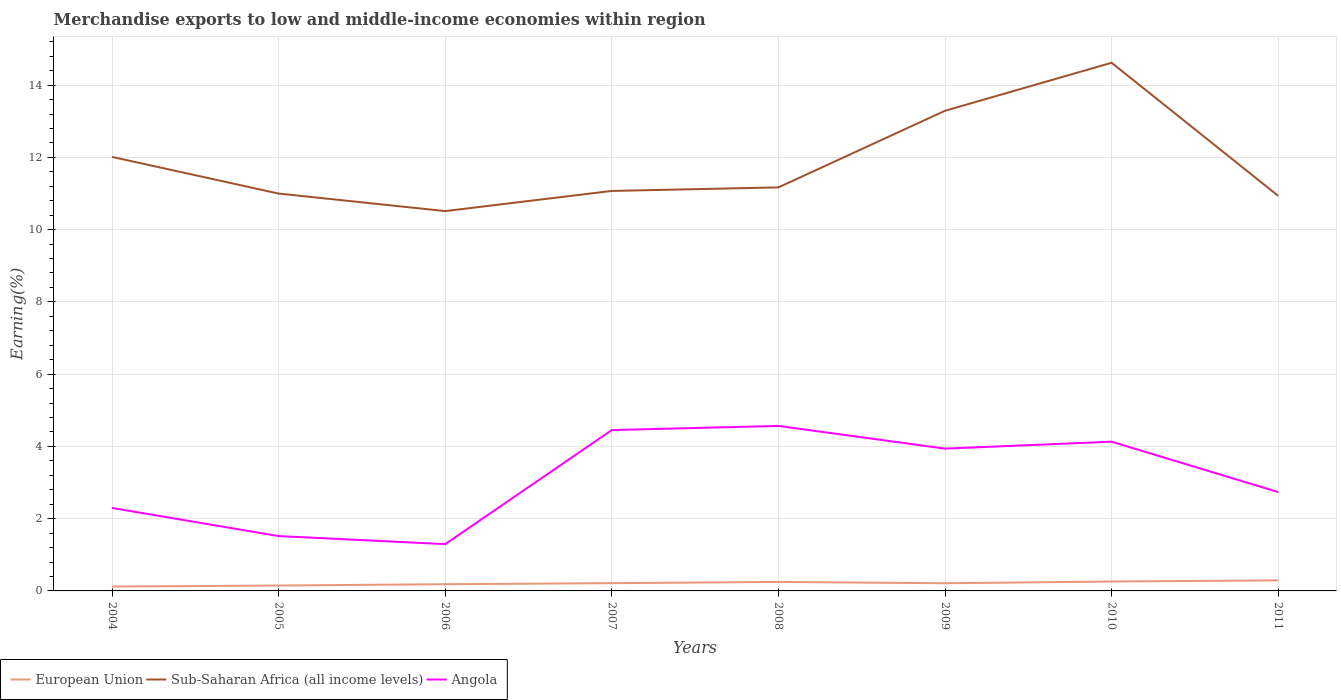Does the line corresponding to Angola intersect with the line corresponding to European Union?
Keep it short and to the point. No. Across all years, what is the maximum percentage of amount earned from merchandise exports in Sub-Saharan Africa (all income levels)?
Your answer should be very brief. 10.51. In which year was the percentage of amount earned from merchandise exports in Angola maximum?
Give a very brief answer. 2006. What is the total percentage of amount earned from merchandise exports in Angola in the graph?
Your answer should be compact. -2.64. What is the difference between the highest and the second highest percentage of amount earned from merchandise exports in Sub-Saharan Africa (all income levels)?
Your answer should be compact. 4.11. How many lines are there?
Your answer should be compact. 3. How many years are there in the graph?
Make the answer very short. 8. Are the values on the major ticks of Y-axis written in scientific E-notation?
Your answer should be compact. No. Does the graph contain any zero values?
Keep it short and to the point. No. Does the graph contain grids?
Your answer should be very brief. Yes. What is the title of the graph?
Offer a terse response. Merchandise exports to low and middle-income economies within region. What is the label or title of the Y-axis?
Offer a very short reply. Earning(%). What is the Earning(%) in European Union in 2004?
Ensure brevity in your answer.  0.12. What is the Earning(%) of Sub-Saharan Africa (all income levels) in 2004?
Your answer should be compact. 12.01. What is the Earning(%) of Angola in 2004?
Your answer should be very brief. 2.3. What is the Earning(%) in European Union in 2005?
Keep it short and to the point. 0.15. What is the Earning(%) of Sub-Saharan Africa (all income levels) in 2005?
Offer a very short reply. 11. What is the Earning(%) in Angola in 2005?
Your answer should be compact. 1.52. What is the Earning(%) of European Union in 2006?
Offer a very short reply. 0.19. What is the Earning(%) of Sub-Saharan Africa (all income levels) in 2006?
Make the answer very short. 10.51. What is the Earning(%) in Angola in 2006?
Provide a succinct answer. 1.3. What is the Earning(%) of European Union in 2007?
Provide a succinct answer. 0.21. What is the Earning(%) in Sub-Saharan Africa (all income levels) in 2007?
Give a very brief answer. 11.07. What is the Earning(%) in Angola in 2007?
Ensure brevity in your answer.  4.45. What is the Earning(%) of European Union in 2008?
Offer a very short reply. 0.25. What is the Earning(%) in Sub-Saharan Africa (all income levels) in 2008?
Your answer should be compact. 11.17. What is the Earning(%) of Angola in 2008?
Give a very brief answer. 4.57. What is the Earning(%) in European Union in 2009?
Offer a terse response. 0.21. What is the Earning(%) of Sub-Saharan Africa (all income levels) in 2009?
Give a very brief answer. 13.29. What is the Earning(%) of Angola in 2009?
Your answer should be very brief. 3.94. What is the Earning(%) in European Union in 2010?
Your answer should be compact. 0.26. What is the Earning(%) of Sub-Saharan Africa (all income levels) in 2010?
Make the answer very short. 14.62. What is the Earning(%) in Angola in 2010?
Provide a short and direct response. 4.13. What is the Earning(%) of European Union in 2011?
Offer a very short reply. 0.29. What is the Earning(%) of Sub-Saharan Africa (all income levels) in 2011?
Your response must be concise. 10.94. What is the Earning(%) in Angola in 2011?
Your response must be concise. 2.74. Across all years, what is the maximum Earning(%) of European Union?
Ensure brevity in your answer.  0.29. Across all years, what is the maximum Earning(%) of Sub-Saharan Africa (all income levels)?
Keep it short and to the point. 14.62. Across all years, what is the maximum Earning(%) in Angola?
Ensure brevity in your answer.  4.57. Across all years, what is the minimum Earning(%) in European Union?
Your answer should be very brief. 0.12. Across all years, what is the minimum Earning(%) of Sub-Saharan Africa (all income levels)?
Give a very brief answer. 10.51. Across all years, what is the minimum Earning(%) in Angola?
Your response must be concise. 1.3. What is the total Earning(%) of European Union in the graph?
Provide a short and direct response. 1.69. What is the total Earning(%) in Sub-Saharan Africa (all income levels) in the graph?
Offer a terse response. 94.61. What is the total Earning(%) of Angola in the graph?
Provide a short and direct response. 24.94. What is the difference between the Earning(%) in European Union in 2004 and that in 2005?
Give a very brief answer. -0.03. What is the difference between the Earning(%) in Angola in 2004 and that in 2005?
Make the answer very short. 0.78. What is the difference between the Earning(%) of European Union in 2004 and that in 2006?
Offer a very short reply. -0.06. What is the difference between the Earning(%) in Sub-Saharan Africa (all income levels) in 2004 and that in 2006?
Give a very brief answer. 1.5. What is the difference between the Earning(%) of Angola in 2004 and that in 2006?
Offer a very short reply. 1. What is the difference between the Earning(%) in European Union in 2004 and that in 2007?
Ensure brevity in your answer.  -0.09. What is the difference between the Earning(%) of Sub-Saharan Africa (all income levels) in 2004 and that in 2007?
Your response must be concise. 0.94. What is the difference between the Earning(%) of Angola in 2004 and that in 2007?
Your answer should be compact. -2.16. What is the difference between the Earning(%) in European Union in 2004 and that in 2008?
Give a very brief answer. -0.13. What is the difference between the Earning(%) in Sub-Saharan Africa (all income levels) in 2004 and that in 2008?
Offer a very short reply. 0.84. What is the difference between the Earning(%) of Angola in 2004 and that in 2008?
Make the answer very short. -2.27. What is the difference between the Earning(%) in European Union in 2004 and that in 2009?
Your response must be concise. -0.09. What is the difference between the Earning(%) in Sub-Saharan Africa (all income levels) in 2004 and that in 2009?
Your answer should be very brief. -1.28. What is the difference between the Earning(%) in Angola in 2004 and that in 2009?
Your response must be concise. -1.64. What is the difference between the Earning(%) in European Union in 2004 and that in 2010?
Your response must be concise. -0.14. What is the difference between the Earning(%) in Sub-Saharan Africa (all income levels) in 2004 and that in 2010?
Provide a short and direct response. -2.61. What is the difference between the Earning(%) in Angola in 2004 and that in 2010?
Give a very brief answer. -1.83. What is the difference between the Earning(%) in European Union in 2004 and that in 2011?
Offer a very short reply. -0.17. What is the difference between the Earning(%) of Sub-Saharan Africa (all income levels) in 2004 and that in 2011?
Keep it short and to the point. 1.08. What is the difference between the Earning(%) of Angola in 2004 and that in 2011?
Provide a succinct answer. -0.44. What is the difference between the Earning(%) in European Union in 2005 and that in 2006?
Your answer should be very brief. -0.04. What is the difference between the Earning(%) in Sub-Saharan Africa (all income levels) in 2005 and that in 2006?
Ensure brevity in your answer.  0.48. What is the difference between the Earning(%) of Angola in 2005 and that in 2006?
Provide a succinct answer. 0.22. What is the difference between the Earning(%) of European Union in 2005 and that in 2007?
Provide a succinct answer. -0.07. What is the difference between the Earning(%) in Sub-Saharan Africa (all income levels) in 2005 and that in 2007?
Ensure brevity in your answer.  -0.07. What is the difference between the Earning(%) in Angola in 2005 and that in 2007?
Make the answer very short. -2.93. What is the difference between the Earning(%) in European Union in 2005 and that in 2008?
Your answer should be compact. -0.1. What is the difference between the Earning(%) in Sub-Saharan Africa (all income levels) in 2005 and that in 2008?
Your answer should be compact. -0.17. What is the difference between the Earning(%) in Angola in 2005 and that in 2008?
Your answer should be compact. -3.05. What is the difference between the Earning(%) of European Union in 2005 and that in 2009?
Offer a terse response. -0.06. What is the difference between the Earning(%) of Sub-Saharan Africa (all income levels) in 2005 and that in 2009?
Your answer should be compact. -2.29. What is the difference between the Earning(%) in Angola in 2005 and that in 2009?
Offer a terse response. -2.42. What is the difference between the Earning(%) of European Union in 2005 and that in 2010?
Keep it short and to the point. -0.11. What is the difference between the Earning(%) of Sub-Saharan Africa (all income levels) in 2005 and that in 2010?
Provide a succinct answer. -3.62. What is the difference between the Earning(%) of Angola in 2005 and that in 2010?
Provide a succinct answer. -2.61. What is the difference between the Earning(%) in European Union in 2005 and that in 2011?
Provide a succinct answer. -0.14. What is the difference between the Earning(%) of Sub-Saharan Africa (all income levels) in 2005 and that in 2011?
Ensure brevity in your answer.  0.06. What is the difference between the Earning(%) of Angola in 2005 and that in 2011?
Offer a very short reply. -1.22. What is the difference between the Earning(%) in European Union in 2006 and that in 2007?
Offer a terse response. -0.03. What is the difference between the Earning(%) in Sub-Saharan Africa (all income levels) in 2006 and that in 2007?
Ensure brevity in your answer.  -0.56. What is the difference between the Earning(%) of Angola in 2006 and that in 2007?
Provide a short and direct response. -3.16. What is the difference between the Earning(%) of European Union in 2006 and that in 2008?
Provide a succinct answer. -0.06. What is the difference between the Earning(%) of Sub-Saharan Africa (all income levels) in 2006 and that in 2008?
Your answer should be compact. -0.66. What is the difference between the Earning(%) of Angola in 2006 and that in 2008?
Keep it short and to the point. -3.27. What is the difference between the Earning(%) in European Union in 2006 and that in 2009?
Offer a terse response. -0.03. What is the difference between the Earning(%) in Sub-Saharan Africa (all income levels) in 2006 and that in 2009?
Your answer should be very brief. -2.78. What is the difference between the Earning(%) of Angola in 2006 and that in 2009?
Your answer should be compact. -2.64. What is the difference between the Earning(%) in European Union in 2006 and that in 2010?
Give a very brief answer. -0.07. What is the difference between the Earning(%) in Sub-Saharan Africa (all income levels) in 2006 and that in 2010?
Provide a short and direct response. -4.11. What is the difference between the Earning(%) in Angola in 2006 and that in 2010?
Your answer should be compact. -2.84. What is the difference between the Earning(%) in European Union in 2006 and that in 2011?
Provide a succinct answer. -0.11. What is the difference between the Earning(%) of Sub-Saharan Africa (all income levels) in 2006 and that in 2011?
Ensure brevity in your answer.  -0.42. What is the difference between the Earning(%) of Angola in 2006 and that in 2011?
Ensure brevity in your answer.  -1.44. What is the difference between the Earning(%) in European Union in 2007 and that in 2008?
Ensure brevity in your answer.  -0.03. What is the difference between the Earning(%) of Sub-Saharan Africa (all income levels) in 2007 and that in 2008?
Keep it short and to the point. -0.1. What is the difference between the Earning(%) in Angola in 2007 and that in 2008?
Keep it short and to the point. -0.11. What is the difference between the Earning(%) in European Union in 2007 and that in 2009?
Keep it short and to the point. 0. What is the difference between the Earning(%) in Sub-Saharan Africa (all income levels) in 2007 and that in 2009?
Keep it short and to the point. -2.22. What is the difference between the Earning(%) in Angola in 2007 and that in 2009?
Offer a terse response. 0.51. What is the difference between the Earning(%) in European Union in 2007 and that in 2010?
Keep it short and to the point. -0.05. What is the difference between the Earning(%) in Sub-Saharan Africa (all income levels) in 2007 and that in 2010?
Offer a very short reply. -3.55. What is the difference between the Earning(%) in Angola in 2007 and that in 2010?
Offer a very short reply. 0.32. What is the difference between the Earning(%) of European Union in 2007 and that in 2011?
Offer a terse response. -0.08. What is the difference between the Earning(%) of Sub-Saharan Africa (all income levels) in 2007 and that in 2011?
Provide a succinct answer. 0.14. What is the difference between the Earning(%) in Angola in 2007 and that in 2011?
Your response must be concise. 1.72. What is the difference between the Earning(%) in European Union in 2008 and that in 2009?
Offer a terse response. 0.04. What is the difference between the Earning(%) in Sub-Saharan Africa (all income levels) in 2008 and that in 2009?
Your answer should be compact. -2.12. What is the difference between the Earning(%) in Angola in 2008 and that in 2009?
Provide a short and direct response. 0.63. What is the difference between the Earning(%) of European Union in 2008 and that in 2010?
Offer a very short reply. -0.01. What is the difference between the Earning(%) in Sub-Saharan Africa (all income levels) in 2008 and that in 2010?
Ensure brevity in your answer.  -3.45. What is the difference between the Earning(%) of Angola in 2008 and that in 2010?
Your answer should be very brief. 0.44. What is the difference between the Earning(%) in European Union in 2008 and that in 2011?
Provide a short and direct response. -0.04. What is the difference between the Earning(%) of Sub-Saharan Africa (all income levels) in 2008 and that in 2011?
Ensure brevity in your answer.  0.23. What is the difference between the Earning(%) of Angola in 2008 and that in 2011?
Your answer should be compact. 1.83. What is the difference between the Earning(%) in European Union in 2009 and that in 2010?
Provide a short and direct response. -0.05. What is the difference between the Earning(%) in Sub-Saharan Africa (all income levels) in 2009 and that in 2010?
Your response must be concise. -1.33. What is the difference between the Earning(%) of Angola in 2009 and that in 2010?
Give a very brief answer. -0.19. What is the difference between the Earning(%) of European Union in 2009 and that in 2011?
Offer a terse response. -0.08. What is the difference between the Earning(%) of Sub-Saharan Africa (all income levels) in 2009 and that in 2011?
Your answer should be very brief. 2.35. What is the difference between the Earning(%) of Angola in 2009 and that in 2011?
Your answer should be compact. 1.2. What is the difference between the Earning(%) of European Union in 2010 and that in 2011?
Offer a terse response. -0.03. What is the difference between the Earning(%) in Sub-Saharan Africa (all income levels) in 2010 and that in 2011?
Your response must be concise. 3.68. What is the difference between the Earning(%) in Angola in 2010 and that in 2011?
Provide a succinct answer. 1.39. What is the difference between the Earning(%) of European Union in 2004 and the Earning(%) of Sub-Saharan Africa (all income levels) in 2005?
Your answer should be very brief. -10.88. What is the difference between the Earning(%) of European Union in 2004 and the Earning(%) of Angola in 2005?
Your response must be concise. -1.4. What is the difference between the Earning(%) of Sub-Saharan Africa (all income levels) in 2004 and the Earning(%) of Angola in 2005?
Provide a succinct answer. 10.5. What is the difference between the Earning(%) of European Union in 2004 and the Earning(%) of Sub-Saharan Africa (all income levels) in 2006?
Your answer should be compact. -10.39. What is the difference between the Earning(%) in European Union in 2004 and the Earning(%) in Angola in 2006?
Offer a very short reply. -1.17. What is the difference between the Earning(%) in Sub-Saharan Africa (all income levels) in 2004 and the Earning(%) in Angola in 2006?
Your answer should be compact. 10.72. What is the difference between the Earning(%) in European Union in 2004 and the Earning(%) in Sub-Saharan Africa (all income levels) in 2007?
Your answer should be very brief. -10.95. What is the difference between the Earning(%) of European Union in 2004 and the Earning(%) of Angola in 2007?
Offer a very short reply. -4.33. What is the difference between the Earning(%) in Sub-Saharan Africa (all income levels) in 2004 and the Earning(%) in Angola in 2007?
Keep it short and to the point. 7.56. What is the difference between the Earning(%) in European Union in 2004 and the Earning(%) in Sub-Saharan Africa (all income levels) in 2008?
Keep it short and to the point. -11.05. What is the difference between the Earning(%) of European Union in 2004 and the Earning(%) of Angola in 2008?
Offer a terse response. -4.45. What is the difference between the Earning(%) in Sub-Saharan Africa (all income levels) in 2004 and the Earning(%) in Angola in 2008?
Give a very brief answer. 7.45. What is the difference between the Earning(%) in European Union in 2004 and the Earning(%) in Sub-Saharan Africa (all income levels) in 2009?
Ensure brevity in your answer.  -13.17. What is the difference between the Earning(%) of European Union in 2004 and the Earning(%) of Angola in 2009?
Provide a succinct answer. -3.82. What is the difference between the Earning(%) in Sub-Saharan Africa (all income levels) in 2004 and the Earning(%) in Angola in 2009?
Provide a short and direct response. 8.07. What is the difference between the Earning(%) of European Union in 2004 and the Earning(%) of Sub-Saharan Africa (all income levels) in 2010?
Provide a succinct answer. -14.5. What is the difference between the Earning(%) of European Union in 2004 and the Earning(%) of Angola in 2010?
Your answer should be very brief. -4.01. What is the difference between the Earning(%) in Sub-Saharan Africa (all income levels) in 2004 and the Earning(%) in Angola in 2010?
Your response must be concise. 7.88. What is the difference between the Earning(%) of European Union in 2004 and the Earning(%) of Sub-Saharan Africa (all income levels) in 2011?
Offer a very short reply. -10.81. What is the difference between the Earning(%) of European Union in 2004 and the Earning(%) of Angola in 2011?
Offer a terse response. -2.62. What is the difference between the Earning(%) in Sub-Saharan Africa (all income levels) in 2004 and the Earning(%) in Angola in 2011?
Offer a terse response. 9.28. What is the difference between the Earning(%) in European Union in 2005 and the Earning(%) in Sub-Saharan Africa (all income levels) in 2006?
Keep it short and to the point. -10.36. What is the difference between the Earning(%) of European Union in 2005 and the Earning(%) of Angola in 2006?
Your answer should be very brief. -1.15. What is the difference between the Earning(%) in Sub-Saharan Africa (all income levels) in 2005 and the Earning(%) in Angola in 2006?
Your answer should be very brief. 9.7. What is the difference between the Earning(%) in European Union in 2005 and the Earning(%) in Sub-Saharan Africa (all income levels) in 2007?
Offer a very short reply. -10.92. What is the difference between the Earning(%) of European Union in 2005 and the Earning(%) of Angola in 2007?
Your answer should be compact. -4.3. What is the difference between the Earning(%) in Sub-Saharan Africa (all income levels) in 2005 and the Earning(%) in Angola in 2007?
Your response must be concise. 6.55. What is the difference between the Earning(%) of European Union in 2005 and the Earning(%) of Sub-Saharan Africa (all income levels) in 2008?
Make the answer very short. -11.02. What is the difference between the Earning(%) of European Union in 2005 and the Earning(%) of Angola in 2008?
Make the answer very short. -4.42. What is the difference between the Earning(%) in Sub-Saharan Africa (all income levels) in 2005 and the Earning(%) in Angola in 2008?
Offer a very short reply. 6.43. What is the difference between the Earning(%) in European Union in 2005 and the Earning(%) in Sub-Saharan Africa (all income levels) in 2009?
Keep it short and to the point. -13.14. What is the difference between the Earning(%) in European Union in 2005 and the Earning(%) in Angola in 2009?
Keep it short and to the point. -3.79. What is the difference between the Earning(%) of Sub-Saharan Africa (all income levels) in 2005 and the Earning(%) of Angola in 2009?
Give a very brief answer. 7.06. What is the difference between the Earning(%) of European Union in 2005 and the Earning(%) of Sub-Saharan Africa (all income levels) in 2010?
Make the answer very short. -14.47. What is the difference between the Earning(%) in European Union in 2005 and the Earning(%) in Angola in 2010?
Your answer should be compact. -3.98. What is the difference between the Earning(%) of Sub-Saharan Africa (all income levels) in 2005 and the Earning(%) of Angola in 2010?
Offer a terse response. 6.87. What is the difference between the Earning(%) of European Union in 2005 and the Earning(%) of Sub-Saharan Africa (all income levels) in 2011?
Your answer should be compact. -10.79. What is the difference between the Earning(%) in European Union in 2005 and the Earning(%) in Angola in 2011?
Give a very brief answer. -2.59. What is the difference between the Earning(%) of Sub-Saharan Africa (all income levels) in 2005 and the Earning(%) of Angola in 2011?
Your answer should be compact. 8.26. What is the difference between the Earning(%) in European Union in 2006 and the Earning(%) in Sub-Saharan Africa (all income levels) in 2007?
Offer a terse response. -10.89. What is the difference between the Earning(%) in European Union in 2006 and the Earning(%) in Angola in 2007?
Your answer should be compact. -4.27. What is the difference between the Earning(%) of Sub-Saharan Africa (all income levels) in 2006 and the Earning(%) of Angola in 2007?
Offer a very short reply. 6.06. What is the difference between the Earning(%) of European Union in 2006 and the Earning(%) of Sub-Saharan Africa (all income levels) in 2008?
Your answer should be very brief. -10.98. What is the difference between the Earning(%) of European Union in 2006 and the Earning(%) of Angola in 2008?
Keep it short and to the point. -4.38. What is the difference between the Earning(%) of Sub-Saharan Africa (all income levels) in 2006 and the Earning(%) of Angola in 2008?
Provide a succinct answer. 5.95. What is the difference between the Earning(%) of European Union in 2006 and the Earning(%) of Sub-Saharan Africa (all income levels) in 2009?
Make the answer very short. -13.1. What is the difference between the Earning(%) of European Union in 2006 and the Earning(%) of Angola in 2009?
Make the answer very short. -3.75. What is the difference between the Earning(%) in Sub-Saharan Africa (all income levels) in 2006 and the Earning(%) in Angola in 2009?
Offer a terse response. 6.58. What is the difference between the Earning(%) in European Union in 2006 and the Earning(%) in Sub-Saharan Africa (all income levels) in 2010?
Offer a very short reply. -14.43. What is the difference between the Earning(%) in European Union in 2006 and the Earning(%) in Angola in 2010?
Your answer should be compact. -3.94. What is the difference between the Earning(%) in Sub-Saharan Africa (all income levels) in 2006 and the Earning(%) in Angola in 2010?
Provide a short and direct response. 6.38. What is the difference between the Earning(%) of European Union in 2006 and the Earning(%) of Sub-Saharan Africa (all income levels) in 2011?
Keep it short and to the point. -10.75. What is the difference between the Earning(%) of European Union in 2006 and the Earning(%) of Angola in 2011?
Make the answer very short. -2.55. What is the difference between the Earning(%) in Sub-Saharan Africa (all income levels) in 2006 and the Earning(%) in Angola in 2011?
Make the answer very short. 7.78. What is the difference between the Earning(%) in European Union in 2007 and the Earning(%) in Sub-Saharan Africa (all income levels) in 2008?
Your response must be concise. -10.95. What is the difference between the Earning(%) of European Union in 2007 and the Earning(%) of Angola in 2008?
Your response must be concise. -4.35. What is the difference between the Earning(%) of Sub-Saharan Africa (all income levels) in 2007 and the Earning(%) of Angola in 2008?
Keep it short and to the point. 6.5. What is the difference between the Earning(%) of European Union in 2007 and the Earning(%) of Sub-Saharan Africa (all income levels) in 2009?
Make the answer very short. -13.07. What is the difference between the Earning(%) in European Union in 2007 and the Earning(%) in Angola in 2009?
Keep it short and to the point. -3.72. What is the difference between the Earning(%) in Sub-Saharan Africa (all income levels) in 2007 and the Earning(%) in Angola in 2009?
Offer a terse response. 7.13. What is the difference between the Earning(%) in European Union in 2007 and the Earning(%) in Sub-Saharan Africa (all income levels) in 2010?
Your answer should be compact. -14.4. What is the difference between the Earning(%) of European Union in 2007 and the Earning(%) of Angola in 2010?
Give a very brief answer. -3.92. What is the difference between the Earning(%) of Sub-Saharan Africa (all income levels) in 2007 and the Earning(%) of Angola in 2010?
Offer a terse response. 6.94. What is the difference between the Earning(%) of European Union in 2007 and the Earning(%) of Sub-Saharan Africa (all income levels) in 2011?
Your answer should be very brief. -10.72. What is the difference between the Earning(%) in European Union in 2007 and the Earning(%) in Angola in 2011?
Offer a terse response. -2.52. What is the difference between the Earning(%) in Sub-Saharan Africa (all income levels) in 2007 and the Earning(%) in Angola in 2011?
Your response must be concise. 8.34. What is the difference between the Earning(%) of European Union in 2008 and the Earning(%) of Sub-Saharan Africa (all income levels) in 2009?
Your response must be concise. -13.04. What is the difference between the Earning(%) of European Union in 2008 and the Earning(%) of Angola in 2009?
Give a very brief answer. -3.69. What is the difference between the Earning(%) of Sub-Saharan Africa (all income levels) in 2008 and the Earning(%) of Angola in 2009?
Offer a terse response. 7.23. What is the difference between the Earning(%) in European Union in 2008 and the Earning(%) in Sub-Saharan Africa (all income levels) in 2010?
Provide a short and direct response. -14.37. What is the difference between the Earning(%) of European Union in 2008 and the Earning(%) of Angola in 2010?
Provide a succinct answer. -3.88. What is the difference between the Earning(%) in Sub-Saharan Africa (all income levels) in 2008 and the Earning(%) in Angola in 2010?
Offer a very short reply. 7.04. What is the difference between the Earning(%) of European Union in 2008 and the Earning(%) of Sub-Saharan Africa (all income levels) in 2011?
Your answer should be compact. -10.69. What is the difference between the Earning(%) of European Union in 2008 and the Earning(%) of Angola in 2011?
Keep it short and to the point. -2.49. What is the difference between the Earning(%) in Sub-Saharan Africa (all income levels) in 2008 and the Earning(%) in Angola in 2011?
Make the answer very short. 8.43. What is the difference between the Earning(%) in European Union in 2009 and the Earning(%) in Sub-Saharan Africa (all income levels) in 2010?
Keep it short and to the point. -14.41. What is the difference between the Earning(%) of European Union in 2009 and the Earning(%) of Angola in 2010?
Offer a very short reply. -3.92. What is the difference between the Earning(%) in Sub-Saharan Africa (all income levels) in 2009 and the Earning(%) in Angola in 2010?
Your answer should be compact. 9.16. What is the difference between the Earning(%) in European Union in 2009 and the Earning(%) in Sub-Saharan Africa (all income levels) in 2011?
Provide a short and direct response. -10.72. What is the difference between the Earning(%) of European Union in 2009 and the Earning(%) of Angola in 2011?
Your answer should be very brief. -2.52. What is the difference between the Earning(%) in Sub-Saharan Africa (all income levels) in 2009 and the Earning(%) in Angola in 2011?
Provide a short and direct response. 10.55. What is the difference between the Earning(%) of European Union in 2010 and the Earning(%) of Sub-Saharan Africa (all income levels) in 2011?
Offer a very short reply. -10.68. What is the difference between the Earning(%) in European Union in 2010 and the Earning(%) in Angola in 2011?
Offer a terse response. -2.48. What is the difference between the Earning(%) in Sub-Saharan Africa (all income levels) in 2010 and the Earning(%) in Angola in 2011?
Provide a succinct answer. 11.88. What is the average Earning(%) in European Union per year?
Offer a terse response. 0.21. What is the average Earning(%) of Sub-Saharan Africa (all income levels) per year?
Make the answer very short. 11.83. What is the average Earning(%) in Angola per year?
Provide a succinct answer. 3.12. In the year 2004, what is the difference between the Earning(%) of European Union and Earning(%) of Sub-Saharan Africa (all income levels)?
Give a very brief answer. -11.89. In the year 2004, what is the difference between the Earning(%) in European Union and Earning(%) in Angola?
Give a very brief answer. -2.18. In the year 2004, what is the difference between the Earning(%) in Sub-Saharan Africa (all income levels) and Earning(%) in Angola?
Provide a short and direct response. 9.72. In the year 2005, what is the difference between the Earning(%) of European Union and Earning(%) of Sub-Saharan Africa (all income levels)?
Ensure brevity in your answer.  -10.85. In the year 2005, what is the difference between the Earning(%) in European Union and Earning(%) in Angola?
Keep it short and to the point. -1.37. In the year 2005, what is the difference between the Earning(%) of Sub-Saharan Africa (all income levels) and Earning(%) of Angola?
Give a very brief answer. 9.48. In the year 2006, what is the difference between the Earning(%) of European Union and Earning(%) of Sub-Saharan Africa (all income levels)?
Provide a short and direct response. -10.33. In the year 2006, what is the difference between the Earning(%) of European Union and Earning(%) of Angola?
Provide a short and direct response. -1.11. In the year 2006, what is the difference between the Earning(%) of Sub-Saharan Africa (all income levels) and Earning(%) of Angola?
Your response must be concise. 9.22. In the year 2007, what is the difference between the Earning(%) in European Union and Earning(%) in Sub-Saharan Africa (all income levels)?
Give a very brief answer. -10.86. In the year 2007, what is the difference between the Earning(%) in European Union and Earning(%) in Angola?
Your answer should be very brief. -4.24. In the year 2007, what is the difference between the Earning(%) in Sub-Saharan Africa (all income levels) and Earning(%) in Angola?
Make the answer very short. 6.62. In the year 2008, what is the difference between the Earning(%) in European Union and Earning(%) in Sub-Saharan Africa (all income levels)?
Ensure brevity in your answer.  -10.92. In the year 2008, what is the difference between the Earning(%) in European Union and Earning(%) in Angola?
Provide a short and direct response. -4.32. In the year 2008, what is the difference between the Earning(%) in Sub-Saharan Africa (all income levels) and Earning(%) in Angola?
Keep it short and to the point. 6.6. In the year 2009, what is the difference between the Earning(%) of European Union and Earning(%) of Sub-Saharan Africa (all income levels)?
Ensure brevity in your answer.  -13.08. In the year 2009, what is the difference between the Earning(%) in European Union and Earning(%) in Angola?
Your answer should be very brief. -3.73. In the year 2009, what is the difference between the Earning(%) in Sub-Saharan Africa (all income levels) and Earning(%) in Angola?
Keep it short and to the point. 9.35. In the year 2010, what is the difference between the Earning(%) of European Union and Earning(%) of Sub-Saharan Africa (all income levels)?
Offer a terse response. -14.36. In the year 2010, what is the difference between the Earning(%) in European Union and Earning(%) in Angola?
Your response must be concise. -3.87. In the year 2010, what is the difference between the Earning(%) in Sub-Saharan Africa (all income levels) and Earning(%) in Angola?
Provide a short and direct response. 10.49. In the year 2011, what is the difference between the Earning(%) in European Union and Earning(%) in Sub-Saharan Africa (all income levels)?
Provide a short and direct response. -10.64. In the year 2011, what is the difference between the Earning(%) in European Union and Earning(%) in Angola?
Your response must be concise. -2.44. In the year 2011, what is the difference between the Earning(%) of Sub-Saharan Africa (all income levels) and Earning(%) of Angola?
Offer a terse response. 8.2. What is the ratio of the Earning(%) in European Union in 2004 to that in 2005?
Give a very brief answer. 0.81. What is the ratio of the Earning(%) of Sub-Saharan Africa (all income levels) in 2004 to that in 2005?
Your answer should be compact. 1.09. What is the ratio of the Earning(%) of Angola in 2004 to that in 2005?
Your answer should be compact. 1.51. What is the ratio of the Earning(%) in European Union in 2004 to that in 2006?
Your answer should be compact. 0.65. What is the ratio of the Earning(%) of Sub-Saharan Africa (all income levels) in 2004 to that in 2006?
Offer a very short reply. 1.14. What is the ratio of the Earning(%) of Angola in 2004 to that in 2006?
Make the answer very short. 1.77. What is the ratio of the Earning(%) in European Union in 2004 to that in 2007?
Ensure brevity in your answer.  0.56. What is the ratio of the Earning(%) in Sub-Saharan Africa (all income levels) in 2004 to that in 2007?
Your response must be concise. 1.09. What is the ratio of the Earning(%) in Angola in 2004 to that in 2007?
Your answer should be compact. 0.52. What is the ratio of the Earning(%) of European Union in 2004 to that in 2008?
Offer a terse response. 0.49. What is the ratio of the Earning(%) of Sub-Saharan Africa (all income levels) in 2004 to that in 2008?
Your response must be concise. 1.08. What is the ratio of the Earning(%) of Angola in 2004 to that in 2008?
Provide a short and direct response. 0.5. What is the ratio of the Earning(%) in European Union in 2004 to that in 2009?
Offer a very short reply. 0.57. What is the ratio of the Earning(%) in Sub-Saharan Africa (all income levels) in 2004 to that in 2009?
Your answer should be compact. 0.9. What is the ratio of the Earning(%) of Angola in 2004 to that in 2009?
Give a very brief answer. 0.58. What is the ratio of the Earning(%) of European Union in 2004 to that in 2010?
Your answer should be compact. 0.46. What is the ratio of the Earning(%) of Sub-Saharan Africa (all income levels) in 2004 to that in 2010?
Provide a short and direct response. 0.82. What is the ratio of the Earning(%) of Angola in 2004 to that in 2010?
Offer a terse response. 0.56. What is the ratio of the Earning(%) of European Union in 2004 to that in 2011?
Provide a short and direct response. 0.41. What is the ratio of the Earning(%) in Sub-Saharan Africa (all income levels) in 2004 to that in 2011?
Ensure brevity in your answer.  1.1. What is the ratio of the Earning(%) in Angola in 2004 to that in 2011?
Give a very brief answer. 0.84. What is the ratio of the Earning(%) of European Union in 2005 to that in 2006?
Provide a succinct answer. 0.8. What is the ratio of the Earning(%) of Sub-Saharan Africa (all income levels) in 2005 to that in 2006?
Provide a short and direct response. 1.05. What is the ratio of the Earning(%) in Angola in 2005 to that in 2006?
Provide a short and direct response. 1.17. What is the ratio of the Earning(%) in European Union in 2005 to that in 2007?
Offer a very short reply. 0.69. What is the ratio of the Earning(%) of Angola in 2005 to that in 2007?
Your response must be concise. 0.34. What is the ratio of the Earning(%) in European Union in 2005 to that in 2008?
Ensure brevity in your answer.  0.6. What is the ratio of the Earning(%) in Sub-Saharan Africa (all income levels) in 2005 to that in 2008?
Your answer should be compact. 0.98. What is the ratio of the Earning(%) in Angola in 2005 to that in 2008?
Offer a terse response. 0.33. What is the ratio of the Earning(%) of European Union in 2005 to that in 2009?
Your answer should be very brief. 0.7. What is the ratio of the Earning(%) of Sub-Saharan Africa (all income levels) in 2005 to that in 2009?
Offer a very short reply. 0.83. What is the ratio of the Earning(%) of Angola in 2005 to that in 2009?
Provide a short and direct response. 0.39. What is the ratio of the Earning(%) in European Union in 2005 to that in 2010?
Provide a short and direct response. 0.57. What is the ratio of the Earning(%) in Sub-Saharan Africa (all income levels) in 2005 to that in 2010?
Offer a terse response. 0.75. What is the ratio of the Earning(%) in Angola in 2005 to that in 2010?
Provide a succinct answer. 0.37. What is the ratio of the Earning(%) in European Union in 2005 to that in 2011?
Your response must be concise. 0.51. What is the ratio of the Earning(%) in Angola in 2005 to that in 2011?
Offer a very short reply. 0.55. What is the ratio of the Earning(%) of European Union in 2006 to that in 2007?
Offer a terse response. 0.86. What is the ratio of the Earning(%) of Sub-Saharan Africa (all income levels) in 2006 to that in 2007?
Provide a short and direct response. 0.95. What is the ratio of the Earning(%) of Angola in 2006 to that in 2007?
Your answer should be very brief. 0.29. What is the ratio of the Earning(%) in European Union in 2006 to that in 2008?
Offer a very short reply. 0.75. What is the ratio of the Earning(%) of Sub-Saharan Africa (all income levels) in 2006 to that in 2008?
Provide a succinct answer. 0.94. What is the ratio of the Earning(%) of Angola in 2006 to that in 2008?
Provide a succinct answer. 0.28. What is the ratio of the Earning(%) of European Union in 2006 to that in 2009?
Your answer should be very brief. 0.87. What is the ratio of the Earning(%) in Sub-Saharan Africa (all income levels) in 2006 to that in 2009?
Your answer should be very brief. 0.79. What is the ratio of the Earning(%) in Angola in 2006 to that in 2009?
Offer a very short reply. 0.33. What is the ratio of the Earning(%) of European Union in 2006 to that in 2010?
Ensure brevity in your answer.  0.71. What is the ratio of the Earning(%) in Sub-Saharan Africa (all income levels) in 2006 to that in 2010?
Your response must be concise. 0.72. What is the ratio of the Earning(%) of Angola in 2006 to that in 2010?
Make the answer very short. 0.31. What is the ratio of the Earning(%) in European Union in 2006 to that in 2011?
Provide a short and direct response. 0.64. What is the ratio of the Earning(%) in Sub-Saharan Africa (all income levels) in 2006 to that in 2011?
Provide a succinct answer. 0.96. What is the ratio of the Earning(%) in Angola in 2006 to that in 2011?
Provide a short and direct response. 0.47. What is the ratio of the Earning(%) of European Union in 2007 to that in 2008?
Your answer should be very brief. 0.86. What is the ratio of the Earning(%) of Angola in 2007 to that in 2008?
Provide a short and direct response. 0.97. What is the ratio of the Earning(%) in European Union in 2007 to that in 2009?
Your response must be concise. 1.01. What is the ratio of the Earning(%) of Sub-Saharan Africa (all income levels) in 2007 to that in 2009?
Your answer should be compact. 0.83. What is the ratio of the Earning(%) in Angola in 2007 to that in 2009?
Offer a terse response. 1.13. What is the ratio of the Earning(%) of European Union in 2007 to that in 2010?
Your answer should be very brief. 0.83. What is the ratio of the Earning(%) in Sub-Saharan Africa (all income levels) in 2007 to that in 2010?
Your response must be concise. 0.76. What is the ratio of the Earning(%) of Angola in 2007 to that in 2010?
Your answer should be compact. 1.08. What is the ratio of the Earning(%) in European Union in 2007 to that in 2011?
Your answer should be very brief. 0.74. What is the ratio of the Earning(%) of Sub-Saharan Africa (all income levels) in 2007 to that in 2011?
Offer a terse response. 1.01. What is the ratio of the Earning(%) in Angola in 2007 to that in 2011?
Provide a succinct answer. 1.63. What is the ratio of the Earning(%) in European Union in 2008 to that in 2009?
Make the answer very short. 1.17. What is the ratio of the Earning(%) of Sub-Saharan Africa (all income levels) in 2008 to that in 2009?
Make the answer very short. 0.84. What is the ratio of the Earning(%) of Angola in 2008 to that in 2009?
Offer a very short reply. 1.16. What is the ratio of the Earning(%) of European Union in 2008 to that in 2010?
Make the answer very short. 0.96. What is the ratio of the Earning(%) in Sub-Saharan Africa (all income levels) in 2008 to that in 2010?
Your answer should be very brief. 0.76. What is the ratio of the Earning(%) of Angola in 2008 to that in 2010?
Make the answer very short. 1.11. What is the ratio of the Earning(%) of European Union in 2008 to that in 2011?
Ensure brevity in your answer.  0.85. What is the ratio of the Earning(%) in Sub-Saharan Africa (all income levels) in 2008 to that in 2011?
Ensure brevity in your answer.  1.02. What is the ratio of the Earning(%) in Angola in 2008 to that in 2011?
Your answer should be compact. 1.67. What is the ratio of the Earning(%) of European Union in 2009 to that in 2010?
Ensure brevity in your answer.  0.82. What is the ratio of the Earning(%) in Sub-Saharan Africa (all income levels) in 2009 to that in 2010?
Ensure brevity in your answer.  0.91. What is the ratio of the Earning(%) of Angola in 2009 to that in 2010?
Your answer should be very brief. 0.95. What is the ratio of the Earning(%) in European Union in 2009 to that in 2011?
Your answer should be very brief. 0.73. What is the ratio of the Earning(%) in Sub-Saharan Africa (all income levels) in 2009 to that in 2011?
Provide a short and direct response. 1.22. What is the ratio of the Earning(%) in Angola in 2009 to that in 2011?
Offer a very short reply. 1.44. What is the ratio of the Earning(%) in European Union in 2010 to that in 2011?
Make the answer very short. 0.89. What is the ratio of the Earning(%) of Sub-Saharan Africa (all income levels) in 2010 to that in 2011?
Give a very brief answer. 1.34. What is the ratio of the Earning(%) of Angola in 2010 to that in 2011?
Your answer should be very brief. 1.51. What is the difference between the highest and the second highest Earning(%) of European Union?
Your answer should be compact. 0.03. What is the difference between the highest and the second highest Earning(%) of Sub-Saharan Africa (all income levels)?
Offer a terse response. 1.33. What is the difference between the highest and the second highest Earning(%) of Angola?
Your answer should be compact. 0.11. What is the difference between the highest and the lowest Earning(%) of European Union?
Offer a terse response. 0.17. What is the difference between the highest and the lowest Earning(%) of Sub-Saharan Africa (all income levels)?
Offer a very short reply. 4.11. What is the difference between the highest and the lowest Earning(%) of Angola?
Keep it short and to the point. 3.27. 